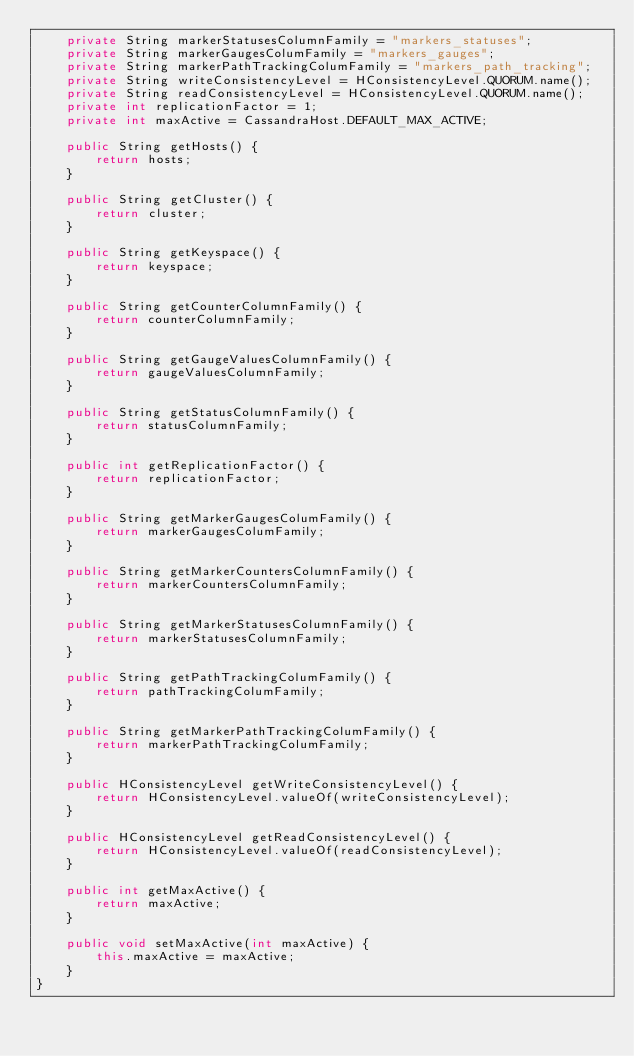<code> <loc_0><loc_0><loc_500><loc_500><_Java_>    private String markerStatusesColumnFamily = "markers_statuses";
    private String markerGaugesColumFamily = "markers_gauges";
    private String markerPathTrackingColumFamily = "markers_path_tracking";
    private String writeConsistencyLevel = HConsistencyLevel.QUORUM.name();
    private String readConsistencyLevel = HConsistencyLevel.QUORUM.name();
    private int replicationFactor = 1;
    private int maxActive = CassandraHost.DEFAULT_MAX_ACTIVE;

    public String getHosts() {
        return hosts;
    }

    public String getCluster() {
        return cluster;
    }

    public String getKeyspace() {
        return keyspace;
    }

    public String getCounterColumnFamily() {
        return counterColumnFamily;
    }

    public String getGaugeValuesColumnFamily() {
        return gaugeValuesColumnFamily;
    }

    public String getStatusColumnFamily() {
        return statusColumnFamily;
    }

    public int getReplicationFactor() {
        return replicationFactor;
    }

    public String getMarkerGaugesColumFamily() {
        return markerGaugesColumFamily;
    }

    public String getMarkerCountersColumnFamily() {
        return markerCountersColumnFamily;
    }

    public String getMarkerStatusesColumnFamily() {
        return markerStatusesColumnFamily;
    }

    public String getPathTrackingColumFamily() {
        return pathTrackingColumFamily;
    }

    public String getMarkerPathTrackingColumFamily() {
        return markerPathTrackingColumFamily;
    }

    public HConsistencyLevel getWriteConsistencyLevel() {
        return HConsistencyLevel.valueOf(writeConsistencyLevel);
    }

    public HConsistencyLevel getReadConsistencyLevel() {
        return HConsistencyLevel.valueOf(readConsistencyLevel);
    }

    public int getMaxActive() {
        return maxActive;
    }

    public void setMaxActive(int maxActive) {
        this.maxActive = maxActive;
    }
}
</code> 